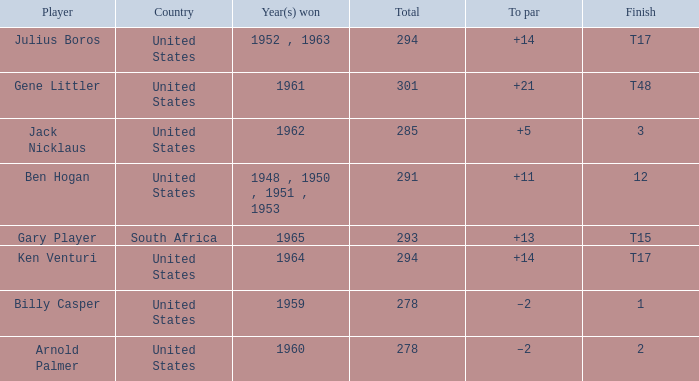What is Country, when Year(s) Won is "1962"? United States. 